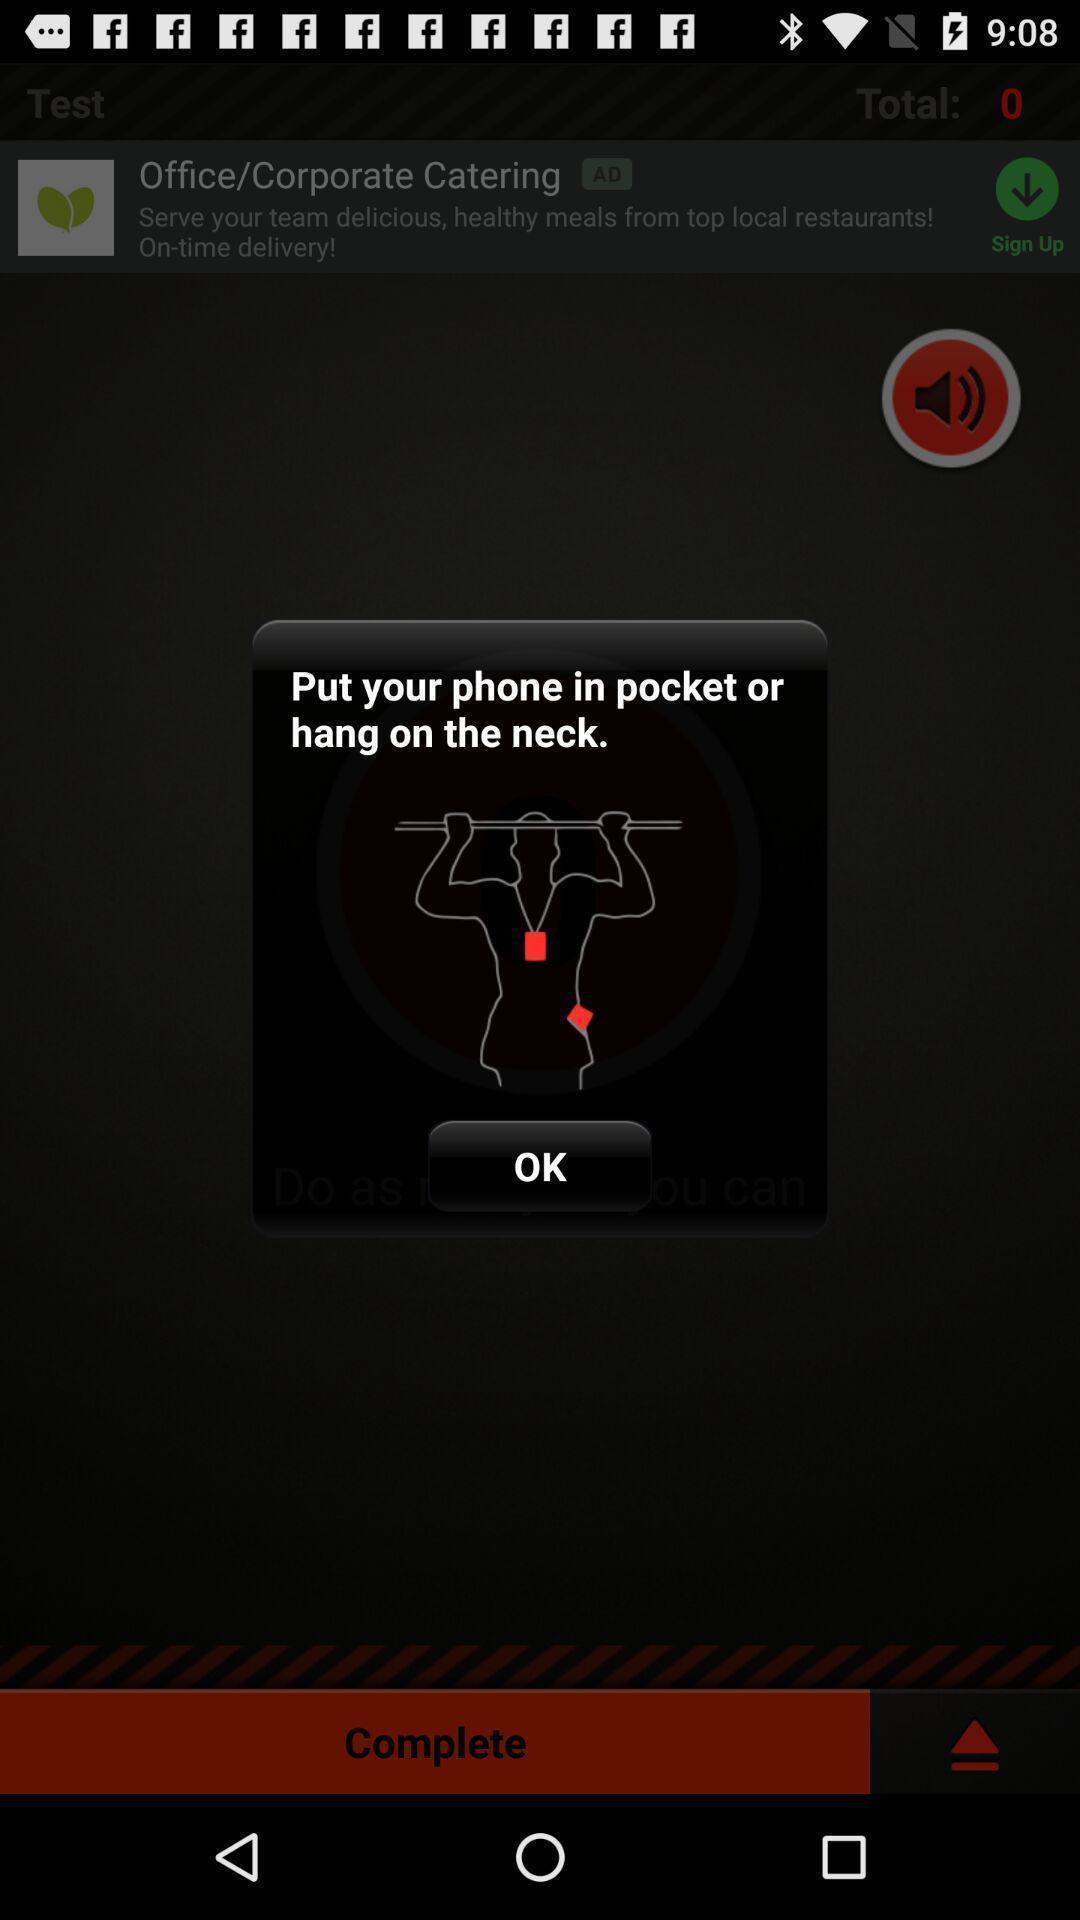Summarize the information in this screenshot. Pop up message with instruction of a fitness app. 